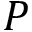Convert formula to latex. <formula><loc_0><loc_0><loc_500><loc_500>P</formula> 